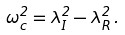Convert formula to latex. <formula><loc_0><loc_0><loc_500><loc_500>\omega ^ { 2 } _ { c } = \lambda ^ { 2 } _ { I } - \lambda ^ { 2 } _ { R } \, .</formula> 